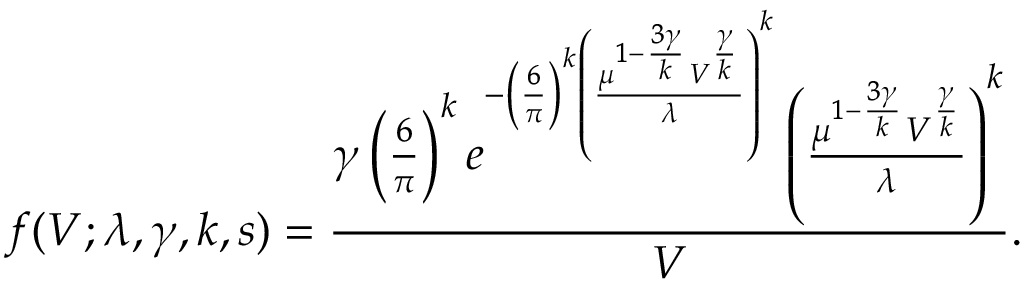<formula> <loc_0><loc_0><loc_500><loc_500>f ( V ; \lambda , \gamma , k , s ) = \frac { \gamma \left ( \frac { 6 } { \pi } \right ) ^ { k } e ^ { - \left ( \frac { 6 } { \pi } \right ) ^ { k } \left ( \frac { \mu ^ { 1 - \frac { 3 \gamma } { k } } V ^ { \frac { \gamma } { k } } } { \lambda } \right ) ^ { k } } \left ( \frac { \mu ^ { 1 - \frac { 3 \gamma } { k } } V ^ { \frac { \gamma } { k } } } { \lambda } \right ) ^ { k } } { V } .</formula> 